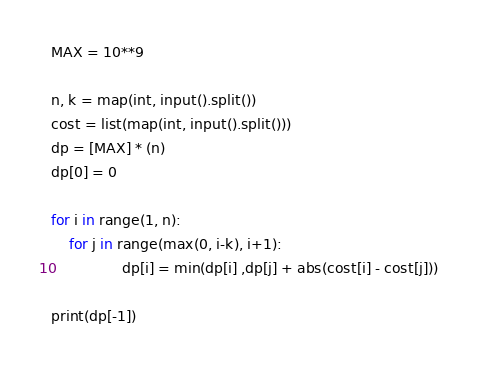<code> <loc_0><loc_0><loc_500><loc_500><_Python_>MAX = 10**9

n, k = map(int, input().split())
cost = list(map(int, input().split()))
dp = [MAX] * (n)
dp[0] = 0

for i in range(1, n):
    for j in range(max(0, i-k), i+1):
                dp[i] = min(dp[i] ,dp[j] + abs(cost[i] - cost[j]))

print(dp[-1])
</code> 